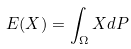<formula> <loc_0><loc_0><loc_500><loc_500>E ( X ) = \int _ { \Omega } X d P</formula> 